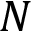<formula> <loc_0><loc_0><loc_500><loc_500>N</formula> 